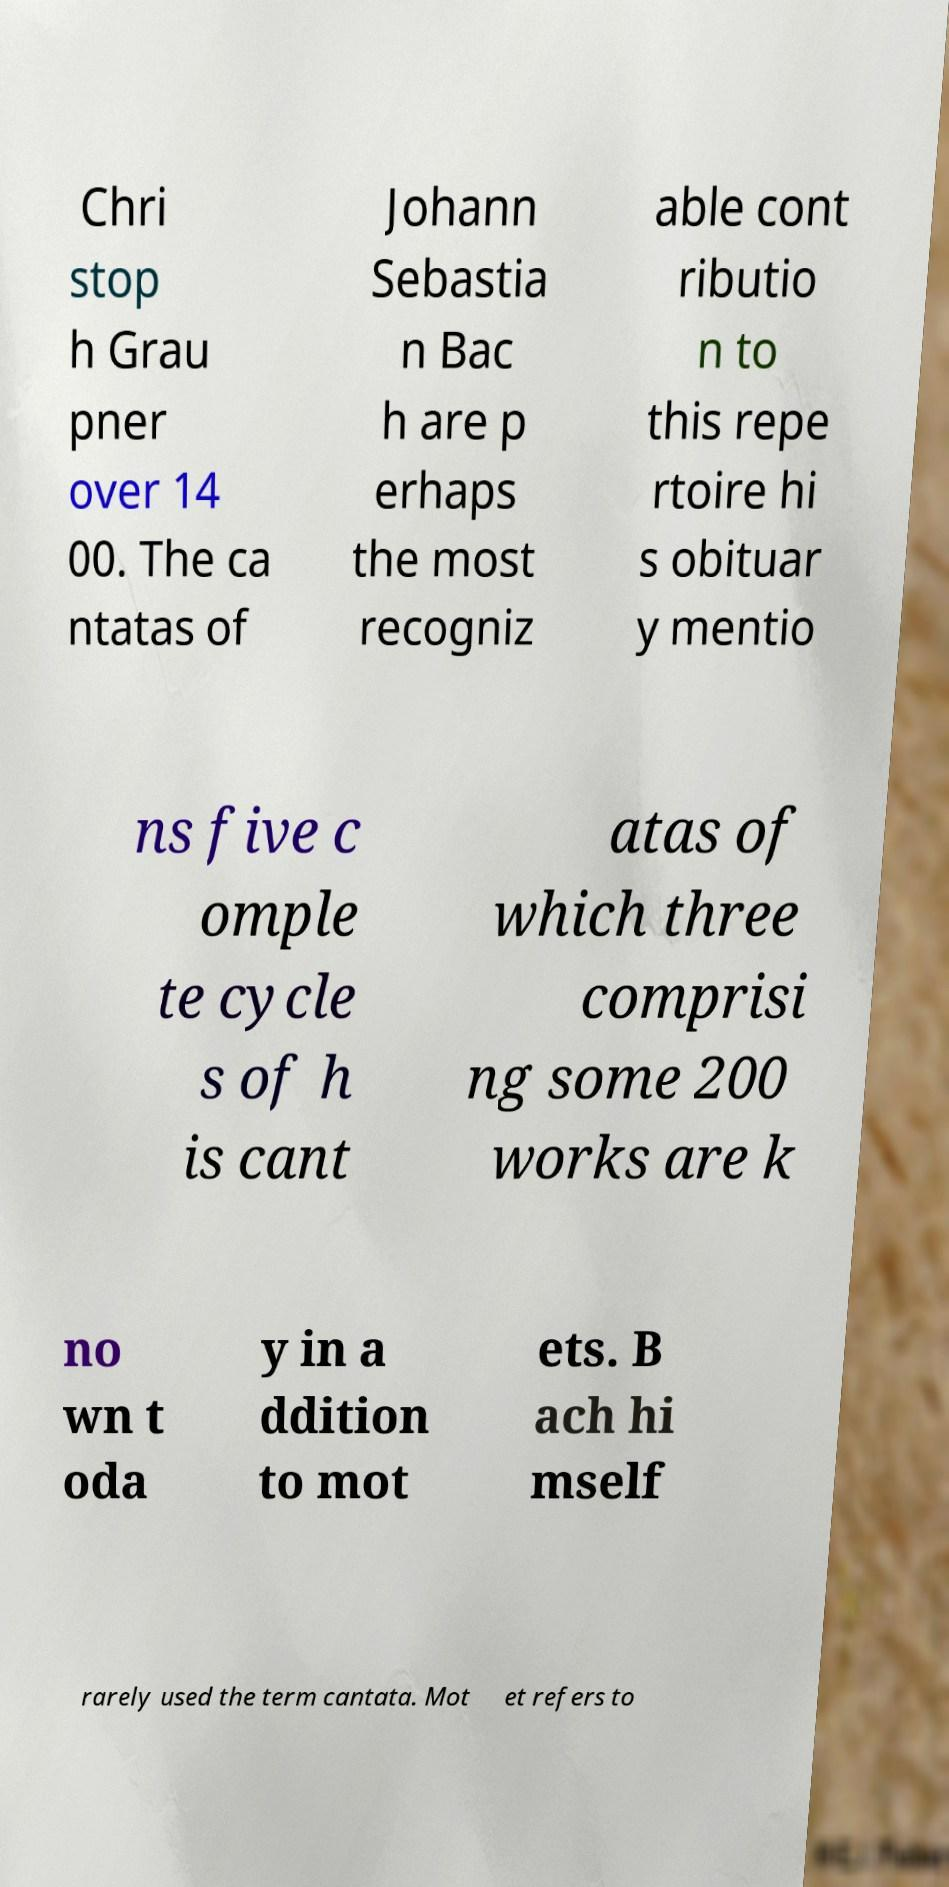Could you extract and type out the text from this image? Chri stop h Grau pner over 14 00. The ca ntatas of Johann Sebastia n Bac h are p erhaps the most recogniz able cont ributio n to this repe rtoire hi s obituar y mentio ns five c omple te cycle s of h is cant atas of which three comprisi ng some 200 works are k no wn t oda y in a ddition to mot ets. B ach hi mself rarely used the term cantata. Mot et refers to 